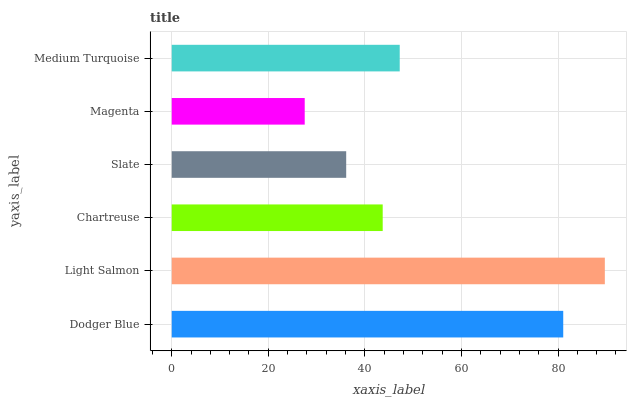Is Magenta the minimum?
Answer yes or no. Yes. Is Light Salmon the maximum?
Answer yes or no. Yes. Is Chartreuse the minimum?
Answer yes or no. No. Is Chartreuse the maximum?
Answer yes or no. No. Is Light Salmon greater than Chartreuse?
Answer yes or no. Yes. Is Chartreuse less than Light Salmon?
Answer yes or no. Yes. Is Chartreuse greater than Light Salmon?
Answer yes or no. No. Is Light Salmon less than Chartreuse?
Answer yes or no. No. Is Medium Turquoise the high median?
Answer yes or no. Yes. Is Chartreuse the low median?
Answer yes or no. Yes. Is Magenta the high median?
Answer yes or no. No. Is Magenta the low median?
Answer yes or no. No. 